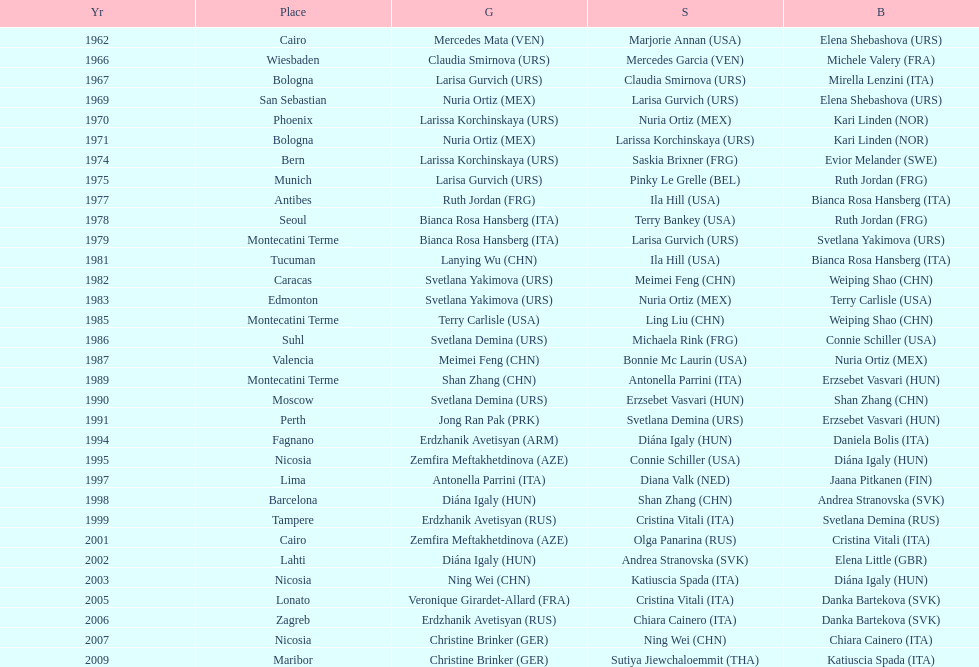What is the total of silver for cairo 0. 